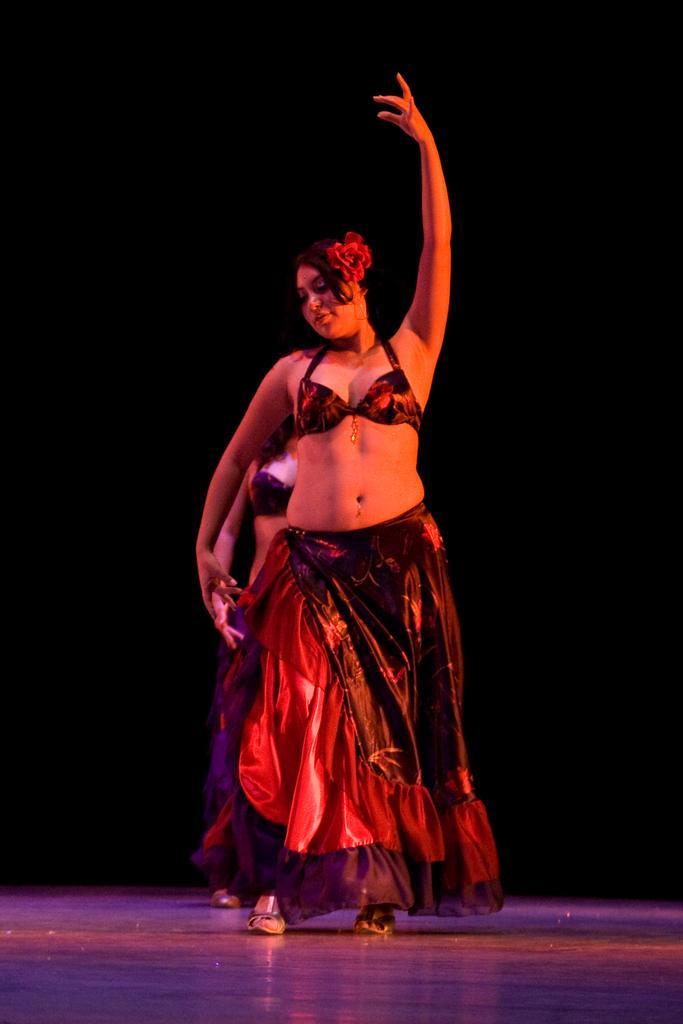How would you summarize this image in a sentence or two? In this image we can see there are two girls dancing on the floor. The background is dark. 